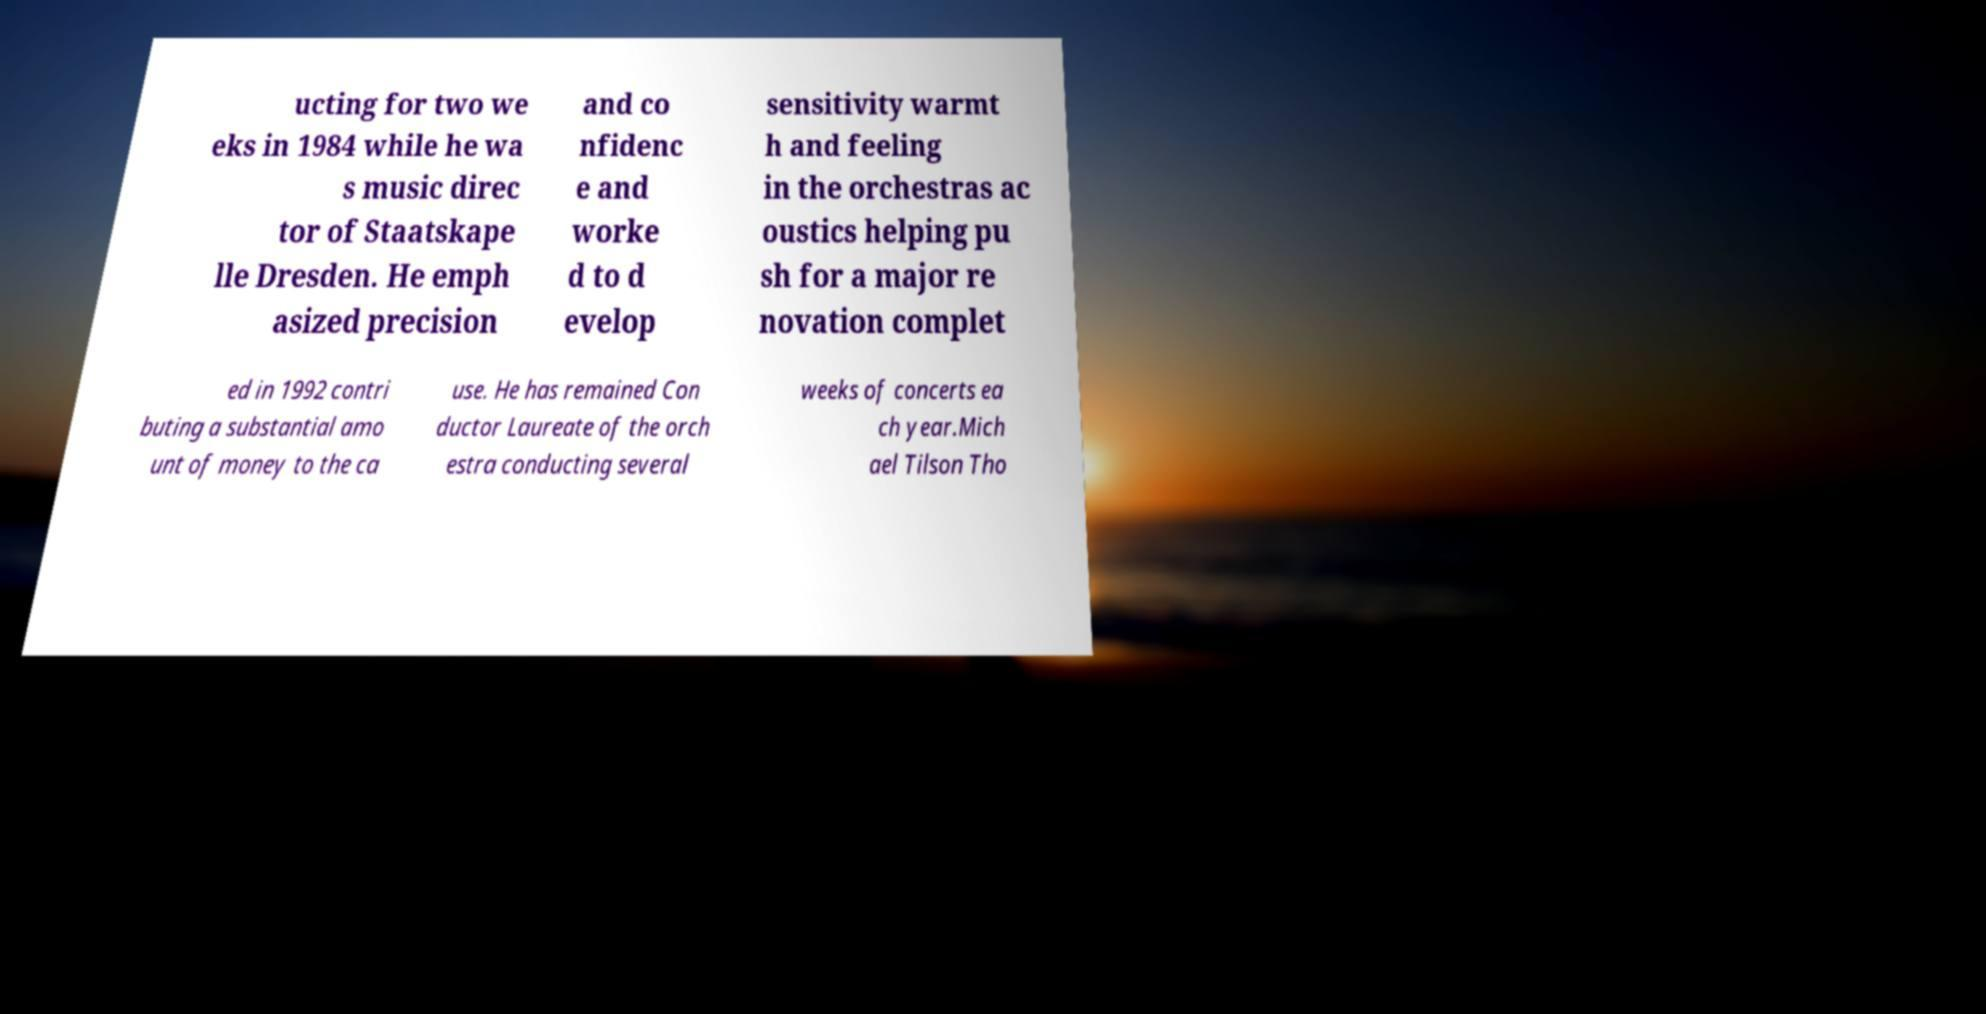What messages or text are displayed in this image? I need them in a readable, typed format. ucting for two we eks in 1984 while he wa s music direc tor of Staatskape lle Dresden. He emph asized precision and co nfidenc e and worke d to d evelop sensitivity warmt h and feeling in the orchestras ac oustics helping pu sh for a major re novation complet ed in 1992 contri buting a substantial amo unt of money to the ca use. He has remained Con ductor Laureate of the orch estra conducting several weeks of concerts ea ch year.Mich ael Tilson Tho 